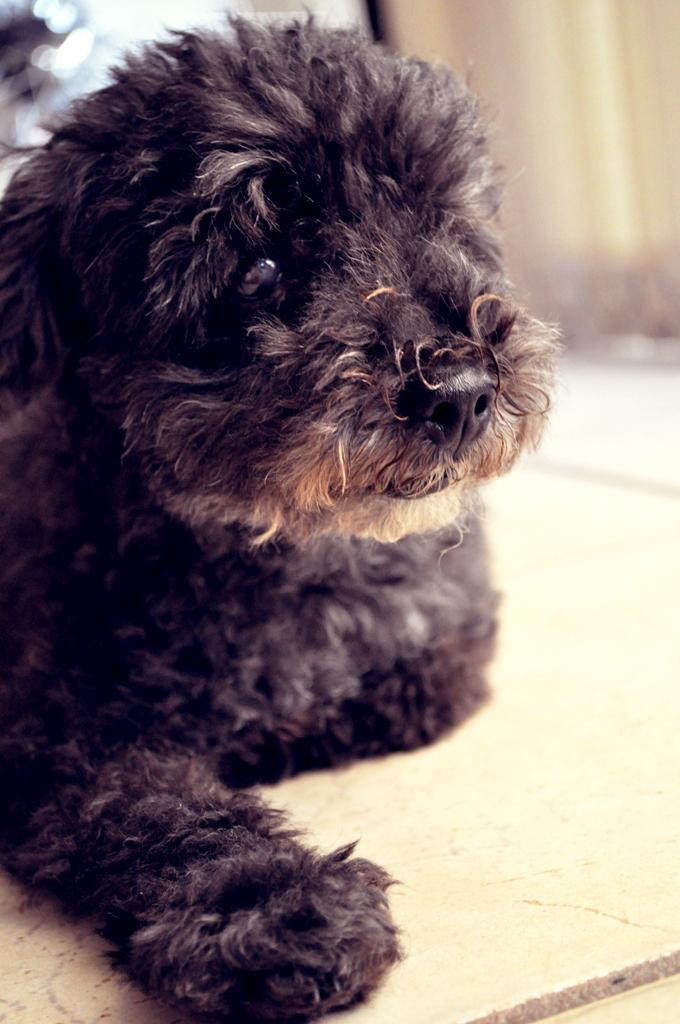What type of animal is in the picture? There is a dog in the picture. Where is the dog located in the image? The dog is on the floor. Can you describe anything in the background of the image? There may be a curtain present in the background of the image. What type of chain is the dog holding in the image? There is no chain present in the image; the dog is simply on the floor. 